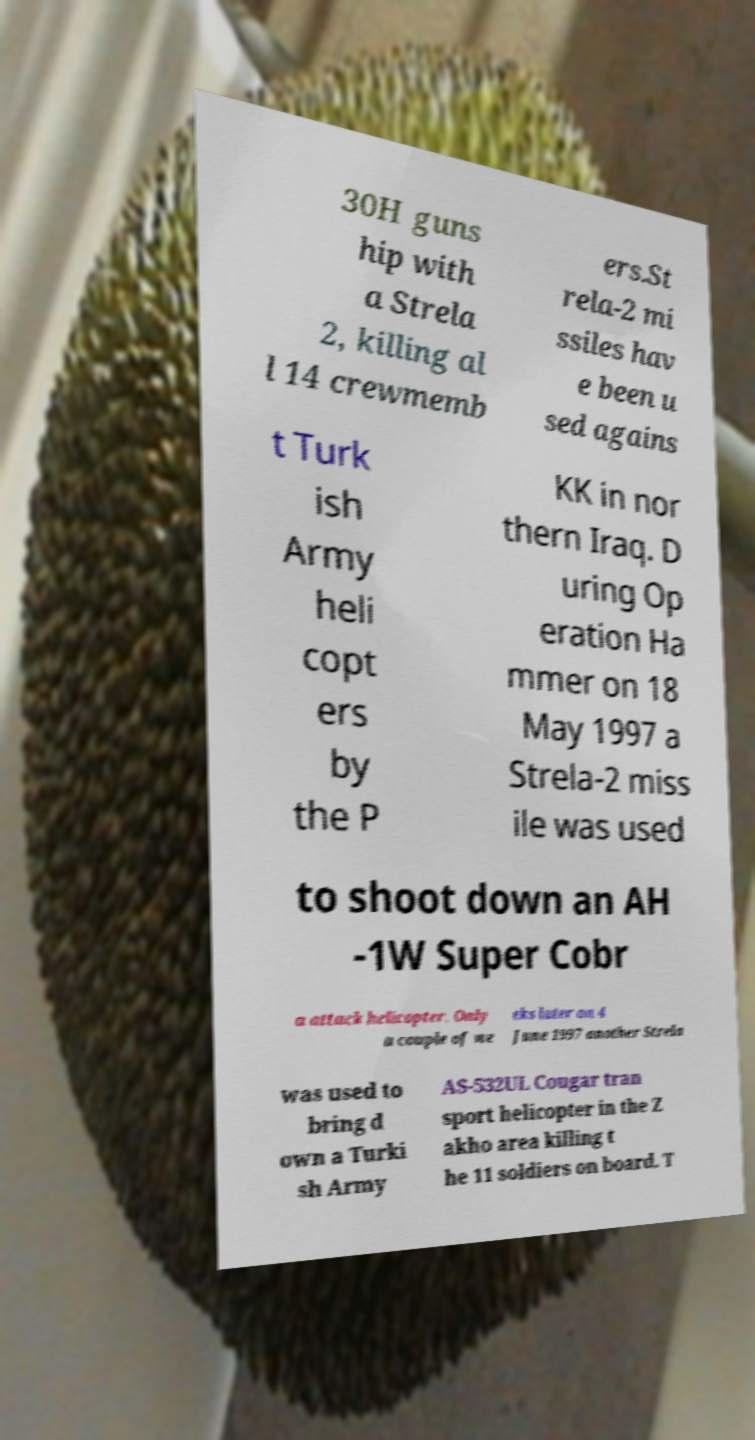For documentation purposes, I need the text within this image transcribed. Could you provide that? 30H guns hip with a Strela 2, killing al l 14 crewmemb ers.St rela-2 mi ssiles hav e been u sed agains t Turk ish Army heli copt ers by the P KK in nor thern Iraq. D uring Op eration Ha mmer on 18 May 1997 a Strela-2 miss ile was used to shoot down an AH -1W Super Cobr a attack helicopter. Only a couple of we eks later on 4 June 1997 another Strela was used to bring d own a Turki sh Army AS-532UL Cougar tran sport helicopter in the Z akho area killing t he 11 soldiers on board. T 